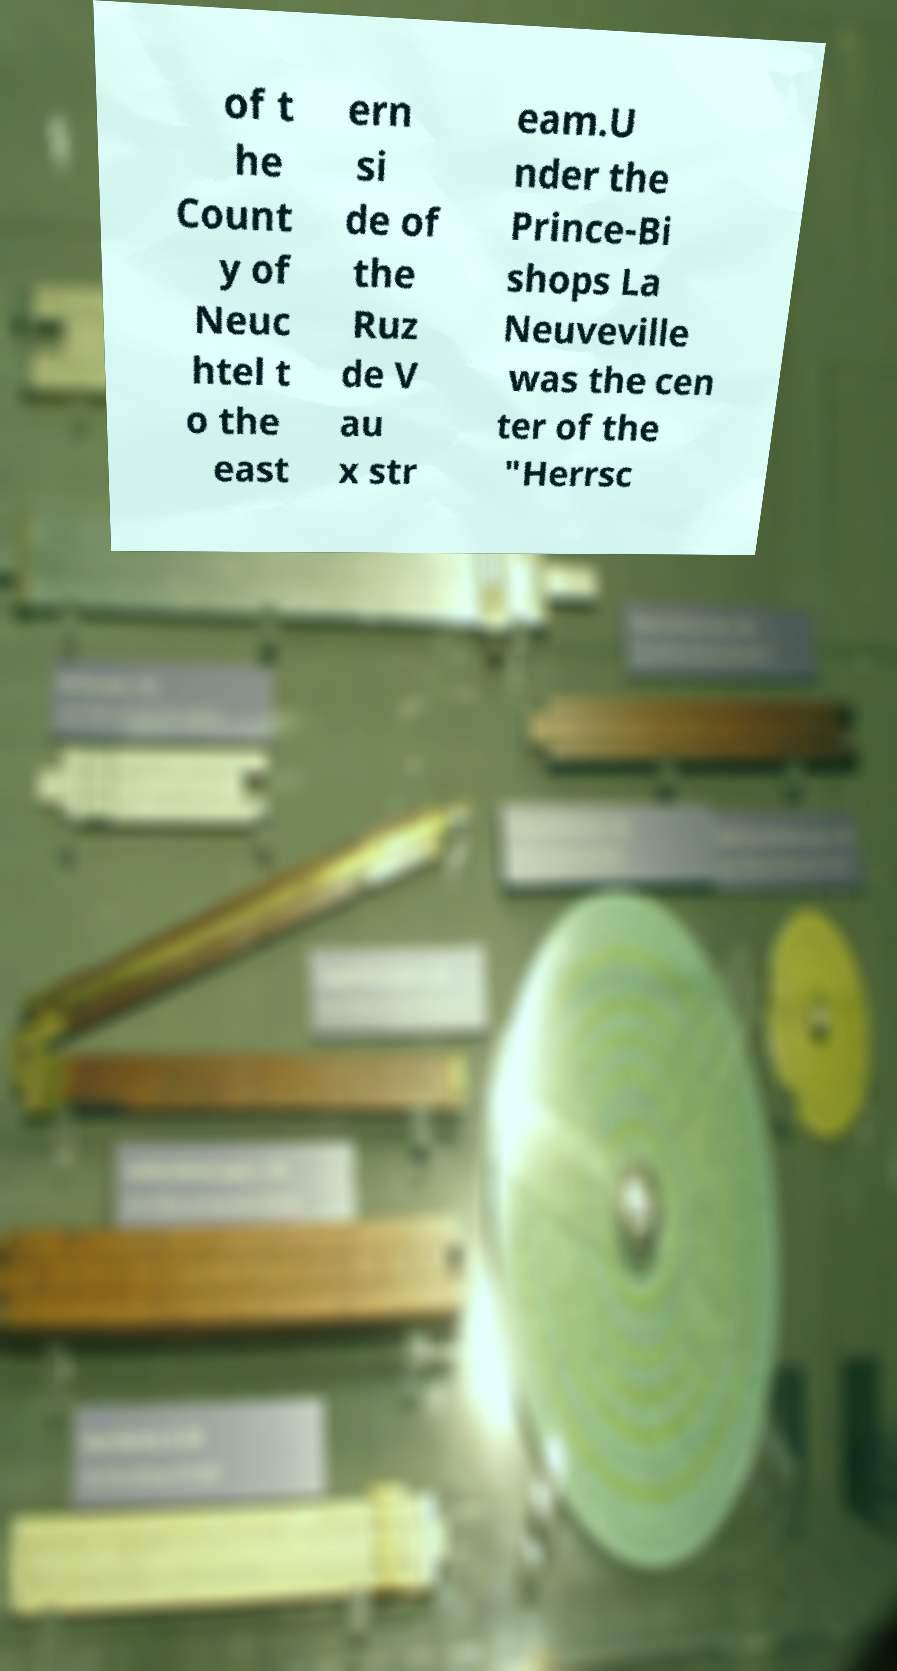Could you assist in decoding the text presented in this image and type it out clearly? of t he Count y of Neuc htel t o the east ern si de of the Ruz de V au x str eam.U nder the Prince-Bi shops La Neuveville was the cen ter of the "Herrsc 